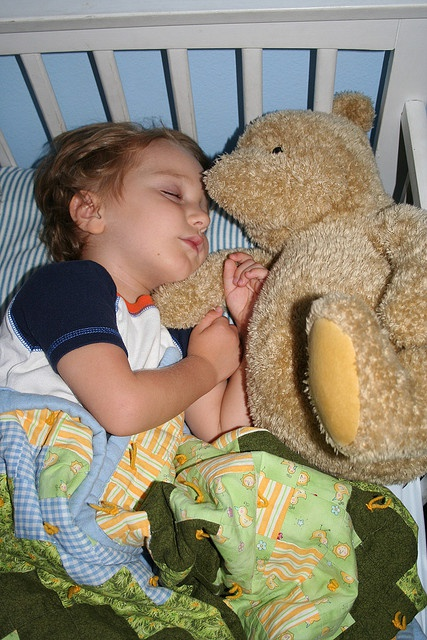Describe the objects in this image and their specific colors. I can see people in darkgray, black, gray, and tan tones, teddy bear in darkgray, tan, and gray tones, and bed in darkgray, gray, and black tones in this image. 